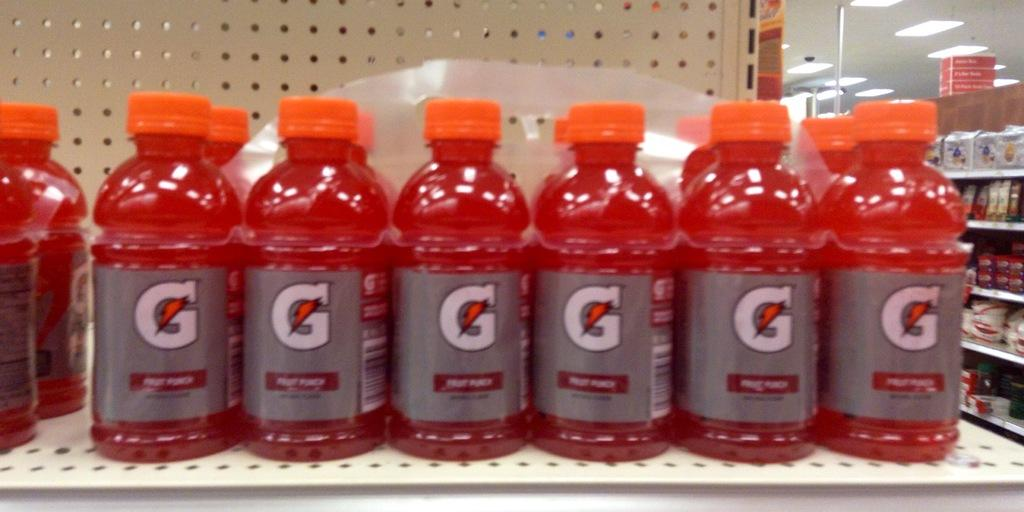<image>
Provide a brief description of the given image. Many red bottles of Gatorade out for sale. 